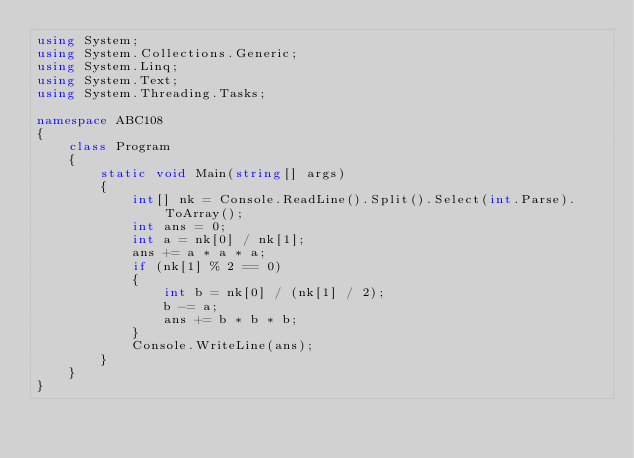Convert code to text. <code><loc_0><loc_0><loc_500><loc_500><_C#_>using System;
using System.Collections.Generic;
using System.Linq;
using System.Text;
using System.Threading.Tasks;

namespace ABC108
{
    class Program
    {
        static void Main(string[] args)
        {
            int[] nk = Console.ReadLine().Split().Select(int.Parse).ToArray();
            int ans = 0;
            int a = nk[0] / nk[1];
            ans += a * a * a;
            if (nk[1] % 2 == 0)
            {
                int b = nk[0] / (nk[1] / 2);
                b -= a;
                ans += b * b * b;
            }
            Console.WriteLine(ans);
        }
    }
}
</code> 